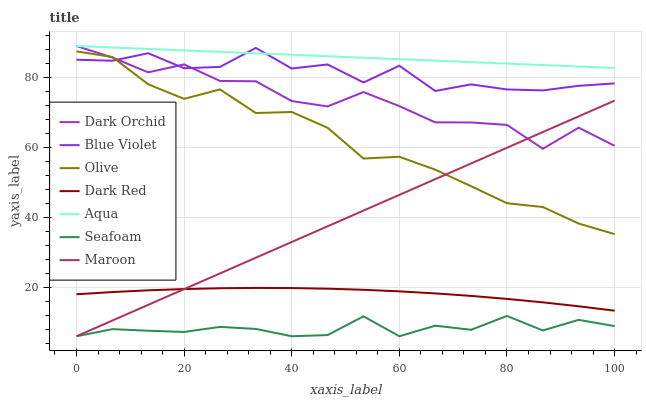Does Seafoam have the minimum area under the curve?
Answer yes or no. Yes. Does Aqua have the maximum area under the curve?
Answer yes or no. Yes. Does Aqua have the minimum area under the curve?
Answer yes or no. No. Does Seafoam have the maximum area under the curve?
Answer yes or no. No. Is Maroon the smoothest?
Answer yes or no. Yes. Is Blue Violet the roughest?
Answer yes or no. Yes. Is Aqua the smoothest?
Answer yes or no. No. Is Aqua the roughest?
Answer yes or no. No. Does Seafoam have the lowest value?
Answer yes or no. Yes. Does Aqua have the lowest value?
Answer yes or no. No. Does Dark Orchid have the highest value?
Answer yes or no. Yes. Does Seafoam have the highest value?
Answer yes or no. No. Is Seafoam less than Dark Red?
Answer yes or no. Yes. Is Olive greater than Dark Red?
Answer yes or no. Yes. Does Blue Violet intersect Dark Orchid?
Answer yes or no. Yes. Is Blue Violet less than Dark Orchid?
Answer yes or no. No. Is Blue Violet greater than Dark Orchid?
Answer yes or no. No. Does Seafoam intersect Dark Red?
Answer yes or no. No. 